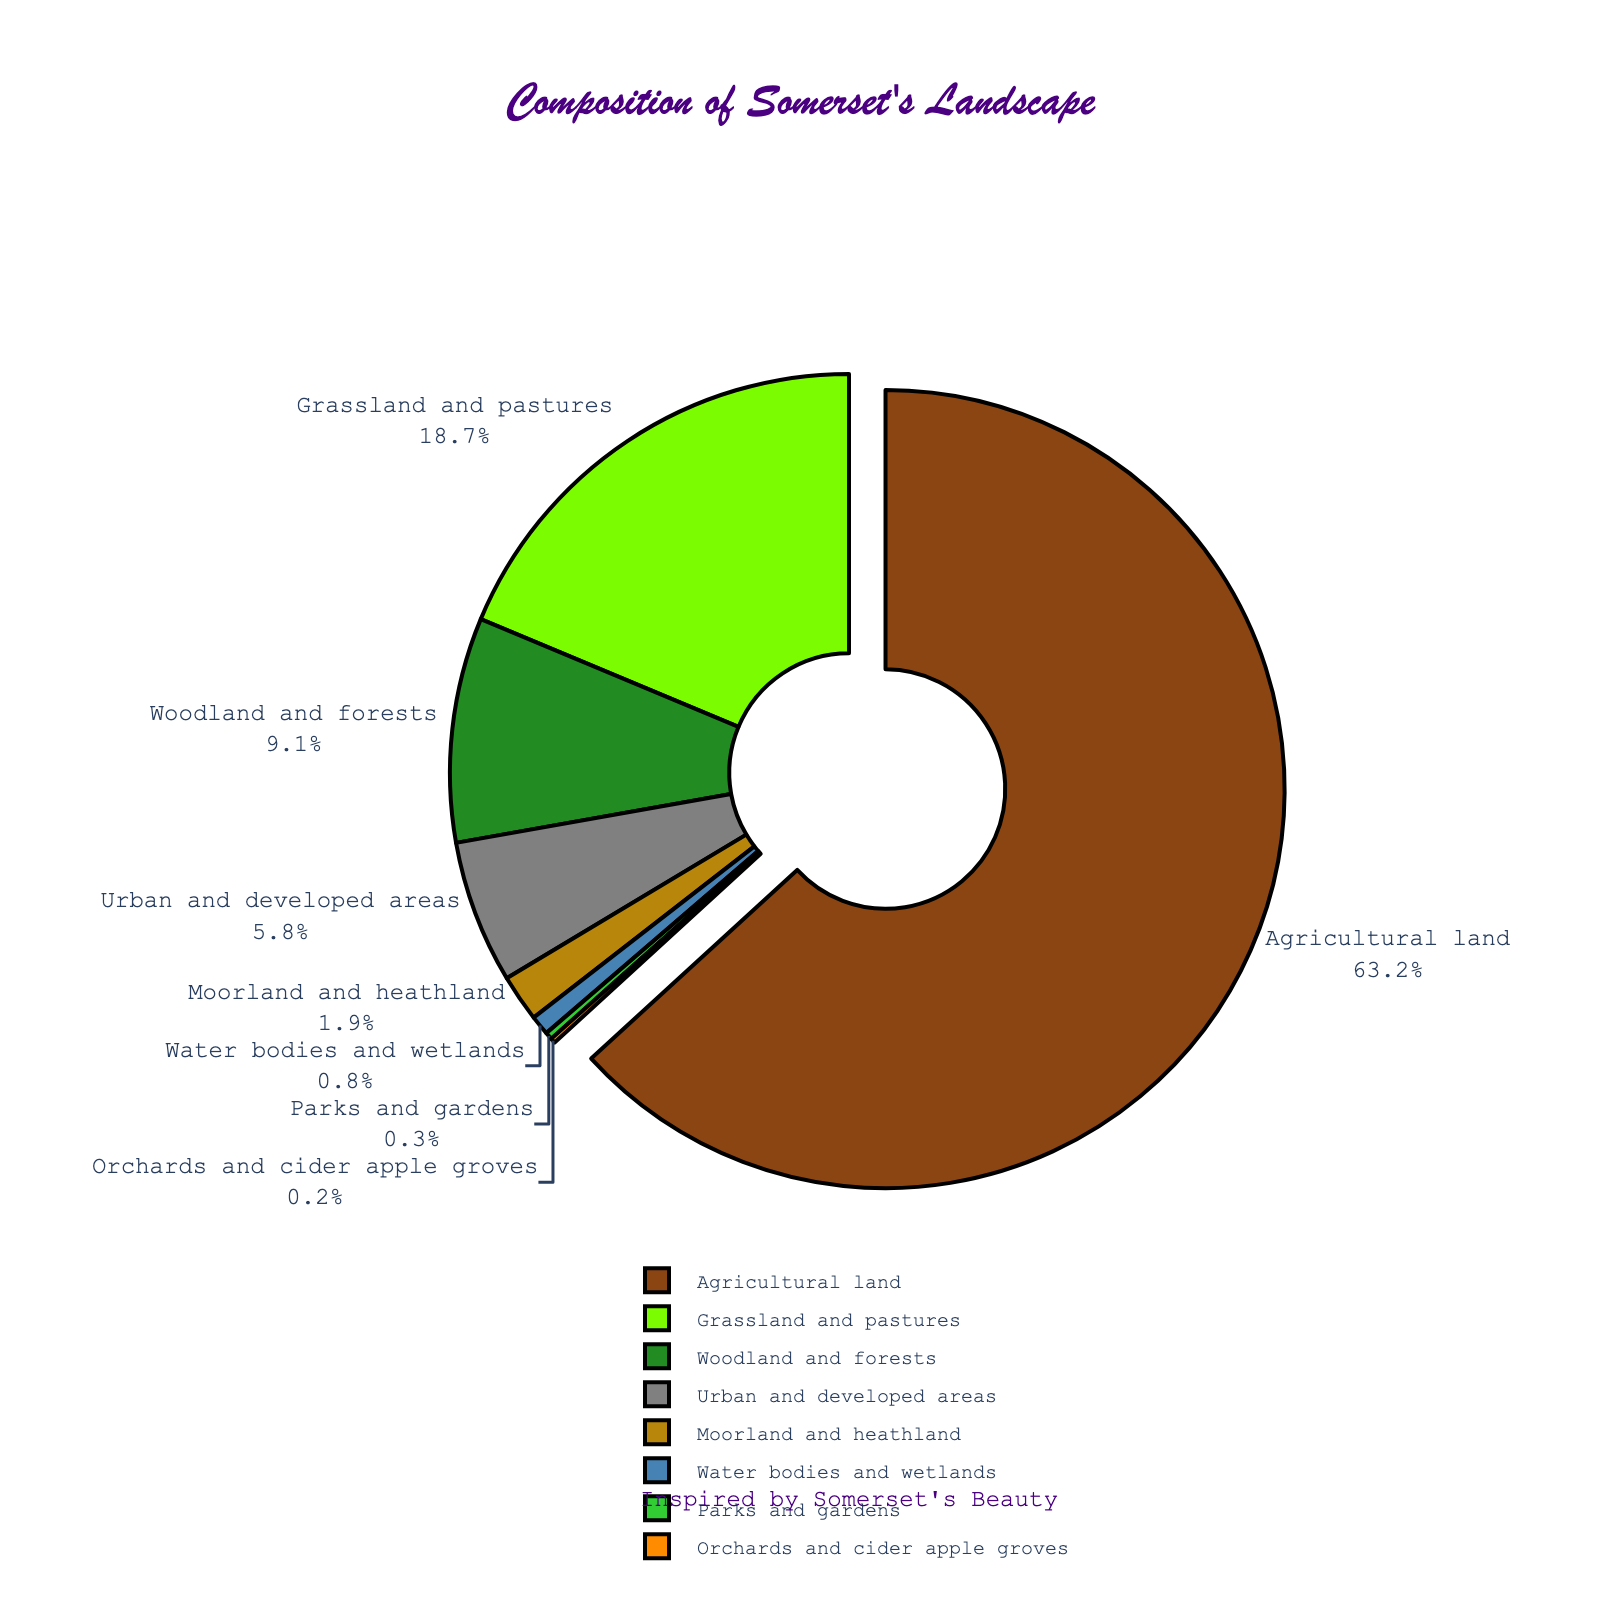What's the percentage of the landscape used for farmland compared to urban areas? The pie chart shows that agricultural land occupies 63.2% of the landscape, while urban and developed areas cover 5.8%. To compare, note that 63.2% is significantly higher than 5.8%.
Answer: Agricultural land is much higher than urban areas What is the combined percentage of woodland, moorland, and water bodies? Add the percentages for woodland and forests (9.1%), moorland and heathland (1.9%), and water bodies and wetlands (0.8%). 9.1 + 1.9 + 0.8 = 11.8%.
Answer: 11.8% Which land use has the smallest representation in Somerset's landscape? Look at the pie chart and identify the category with the smallest slice and percentage. Orchards and cider apple groves have the smallest representation at 0.2%.
Answer: Orchards and cider apple groves Is the percentage of grassland and pastures greater or less than 20%? The pie chart shows grassland and pastures at 18.7%. Compare 18.7% to 20%. 18.7% is less than 20%.
Answer: Less How much larger is the agricultural land percentage compared to grassland and pastures? Subtract the percentage of grassland and pastures (18.7%) from the agricultural land percentage (63.2%). 63.2 - 18.7 = 44.5%.
Answer: 44.5% What color represents woodland and forests in the pie chart? Observe the pie chart and identify the color associated with the slice labeled "Woodland and forests".
Answer: Green By how much does the percentage of urban areas exceed the combined percentage of parks and gardens, and orchards and cider apple groves? Add the percentages of parks and gardens (0.3%) and orchards and cider apple groves (0.2%) to get 0.5%. Subtract this sum from the urban and developed areas percentage (5.8%). 5.8 - 0.5 = 5.3%.
Answer: 5.3% Which three categories together cover less than 5% of the landscape? Look for the smallest slices of the pie chart and sum them until the total exceeds 5%. Parks and gardens (0.3%), orchards and cider apple groves (0.2%), and water bodies and wetlands (0.8%) together cover only 1.3%, therefore include moorland and heathland (1.9%) for a total of less than 5%.
Answer: Parks and gardens, orchards and cider apple groves, water bodies and wetlands 